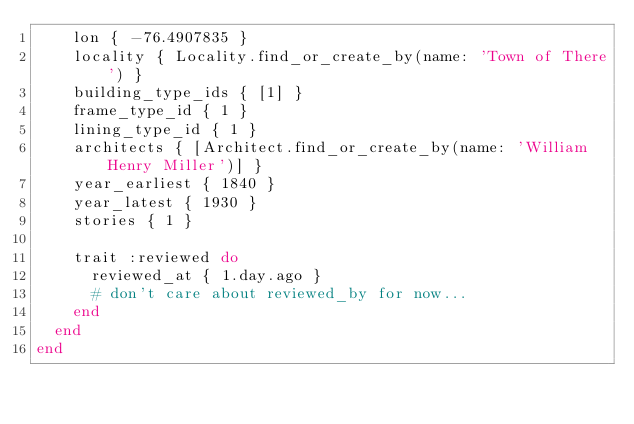<code> <loc_0><loc_0><loc_500><loc_500><_Ruby_>    lon { -76.4907835 }
    locality { Locality.find_or_create_by(name: 'Town of There') }
    building_type_ids { [1] }
    frame_type_id { 1 }
    lining_type_id { 1 }
    architects { [Architect.find_or_create_by(name: 'William Henry Miller')] }
    year_earliest { 1840 }
    year_latest { 1930 }
    stories { 1 }

    trait :reviewed do
      reviewed_at { 1.day.ago }
      # don't care about reviewed_by for now...
    end
  end
end
</code> 